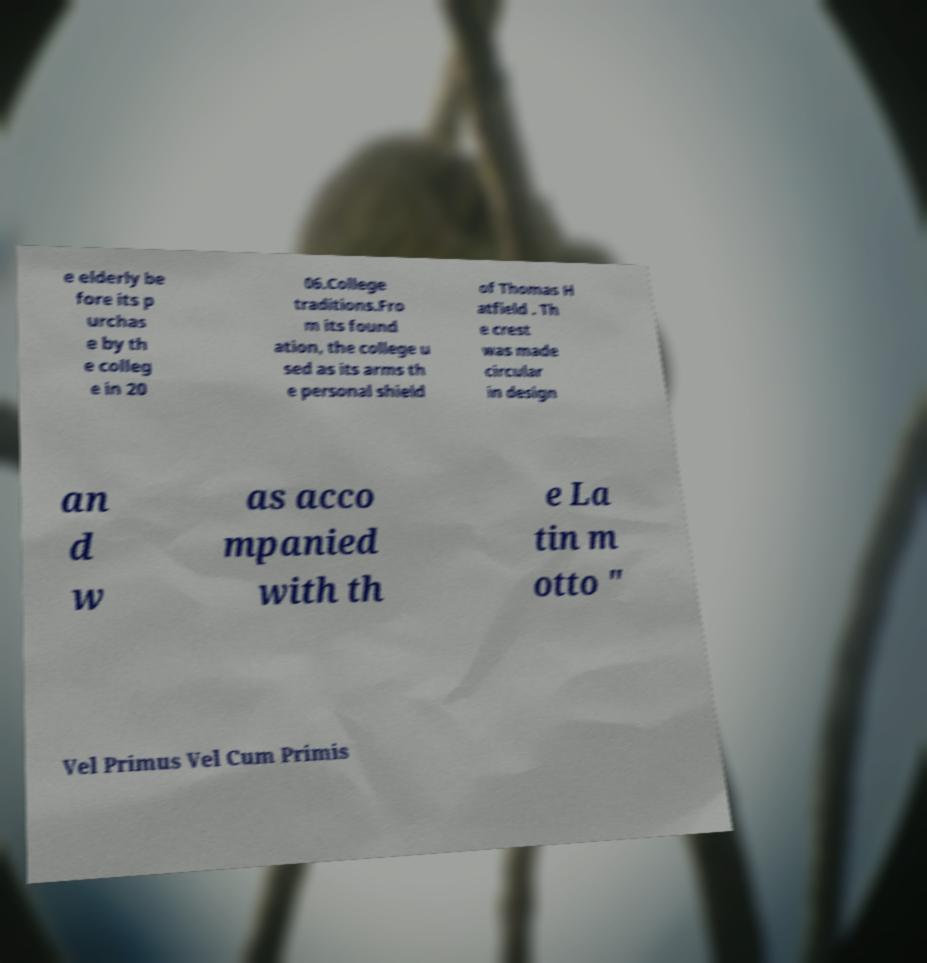What messages or text are displayed in this image? I need them in a readable, typed format. e elderly be fore its p urchas e by th e colleg e in 20 06.College traditions.Fro m its found ation, the college u sed as its arms th e personal shield of Thomas H atfield . Th e crest was made circular in design an d w as acco mpanied with th e La tin m otto " Vel Primus Vel Cum Primis 